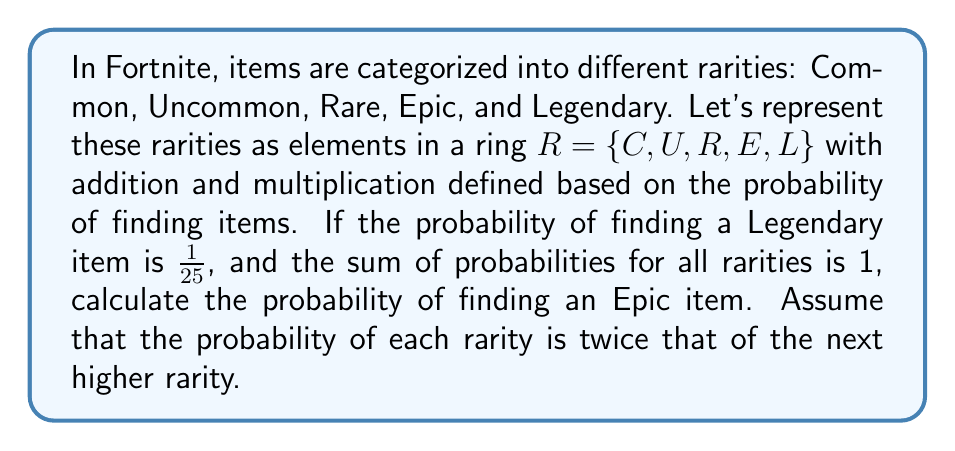Can you solve this math problem? Let's approach this step-by-step using ring theory concepts:

1) First, let's define our ring $R = \{C, U, R, E, L\}$ where each element represents a rarity.

2) We're given that the probability of finding a Legendary item (L) is $1/25$.

3) We're told that the probability of each rarity is twice that of the next higher rarity. So, if we denote the probability of finding an Epic item as $x$, we can express the probabilities as:

   $P(L) = \frac{1}{25}$
   $P(E) = x$
   $P(R) = 2x$
   $P(U) = 4x$
   $P(C) = 8x$

4) We know that the sum of all probabilities must equal 1:

   $$\frac{1}{25} + x + 2x + 4x + 8x = 1$$

5) Simplifying:

   $$\frac{1}{25} + 15x = 1$$

6) Solving for $x$:

   $$15x = 1 - \frac{1}{25} = \frac{24}{25}$$
   $$x = \frac{24}{25} \cdot \frac{1}{15} = \frac{8}{25}$$

7) Therefore, the probability of finding an Epic item is $\frac{8}{25}$.

In ring theory terms, we've used the additive property of the ring to solve this problem, where the sum of all elements (probabilities) equals the identity element (1) in the ring of real numbers under addition.
Answer: $\frac{8}{25}$ or 0.32 or 32% 